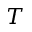<formula> <loc_0><loc_0><loc_500><loc_500>T</formula> 